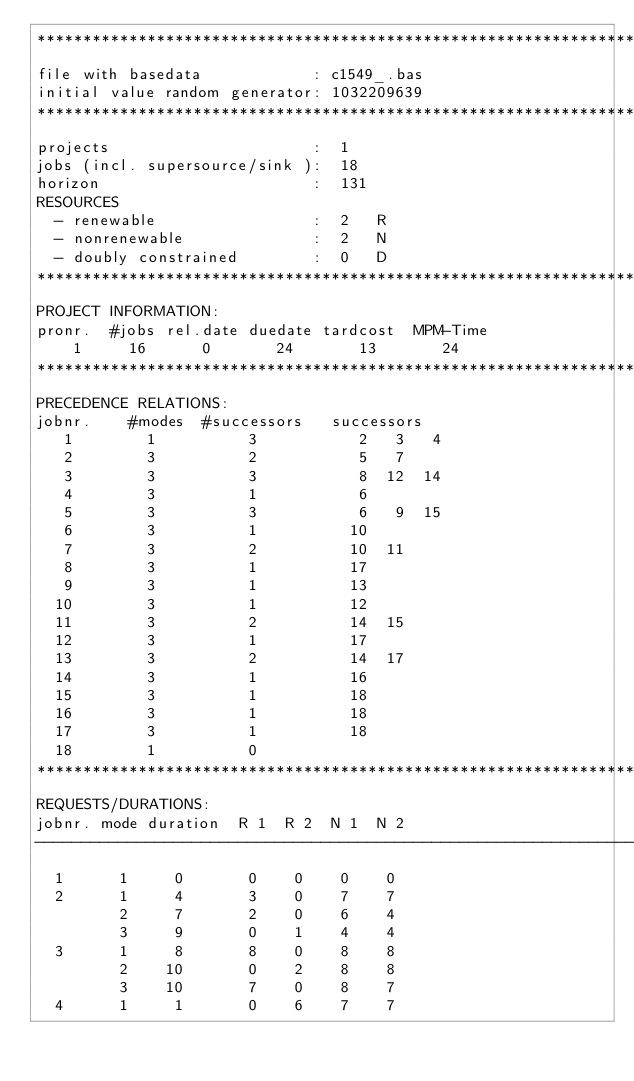Convert code to text. <code><loc_0><loc_0><loc_500><loc_500><_ObjectiveC_>************************************************************************
file with basedata            : c1549_.bas
initial value random generator: 1032209639
************************************************************************
projects                      :  1
jobs (incl. supersource/sink ):  18
horizon                       :  131
RESOURCES
  - renewable                 :  2   R
  - nonrenewable              :  2   N
  - doubly constrained        :  0   D
************************************************************************
PROJECT INFORMATION:
pronr.  #jobs rel.date duedate tardcost  MPM-Time
    1     16      0       24       13       24
************************************************************************
PRECEDENCE RELATIONS:
jobnr.    #modes  #successors   successors
   1        1          3           2   3   4
   2        3          2           5   7
   3        3          3           8  12  14
   4        3          1           6
   5        3          3           6   9  15
   6        3          1          10
   7        3          2          10  11
   8        3          1          17
   9        3          1          13
  10        3          1          12
  11        3          2          14  15
  12        3          1          17
  13        3          2          14  17
  14        3          1          16
  15        3          1          18
  16        3          1          18
  17        3          1          18
  18        1          0        
************************************************************************
REQUESTS/DURATIONS:
jobnr. mode duration  R 1  R 2  N 1  N 2
------------------------------------------------------------------------
  1      1     0       0    0    0    0
  2      1     4       3    0    7    7
         2     7       2    0    6    4
         3     9       0    1    4    4
  3      1     8       8    0    8    8
         2    10       0    2    8    8
         3    10       7    0    8    7
  4      1     1       0    6    7    7</code> 